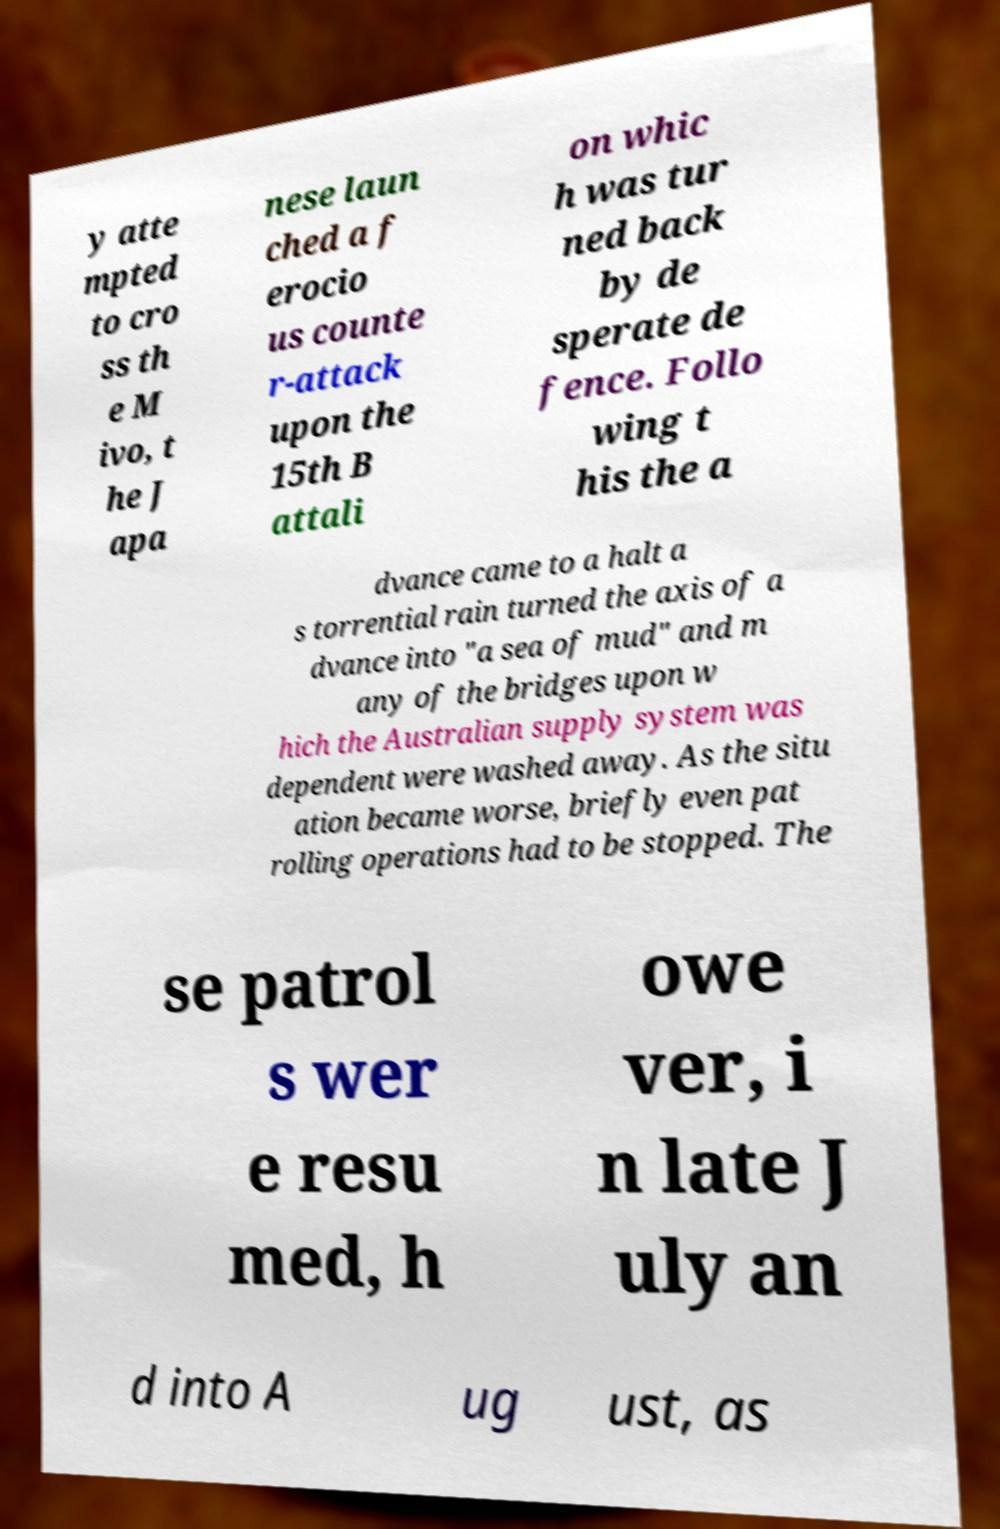What messages or text are displayed in this image? I need them in a readable, typed format. y atte mpted to cro ss th e M ivo, t he J apa nese laun ched a f erocio us counte r-attack upon the 15th B attali on whic h was tur ned back by de sperate de fence. Follo wing t his the a dvance came to a halt a s torrential rain turned the axis of a dvance into "a sea of mud" and m any of the bridges upon w hich the Australian supply system was dependent were washed away. As the situ ation became worse, briefly even pat rolling operations had to be stopped. The se patrol s wer e resu med, h owe ver, i n late J uly an d into A ug ust, as 